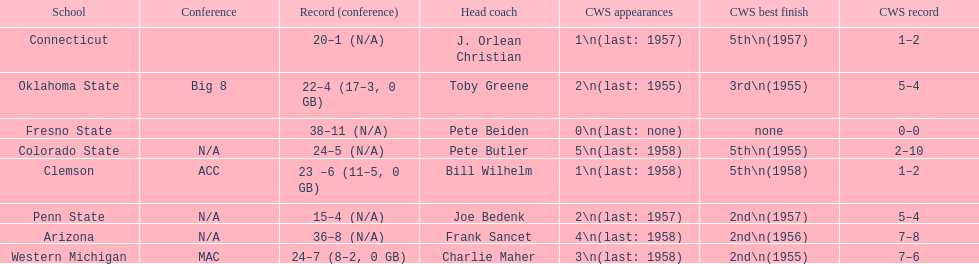Oklahoma state and penn state both have how many cws appearances? 2. 